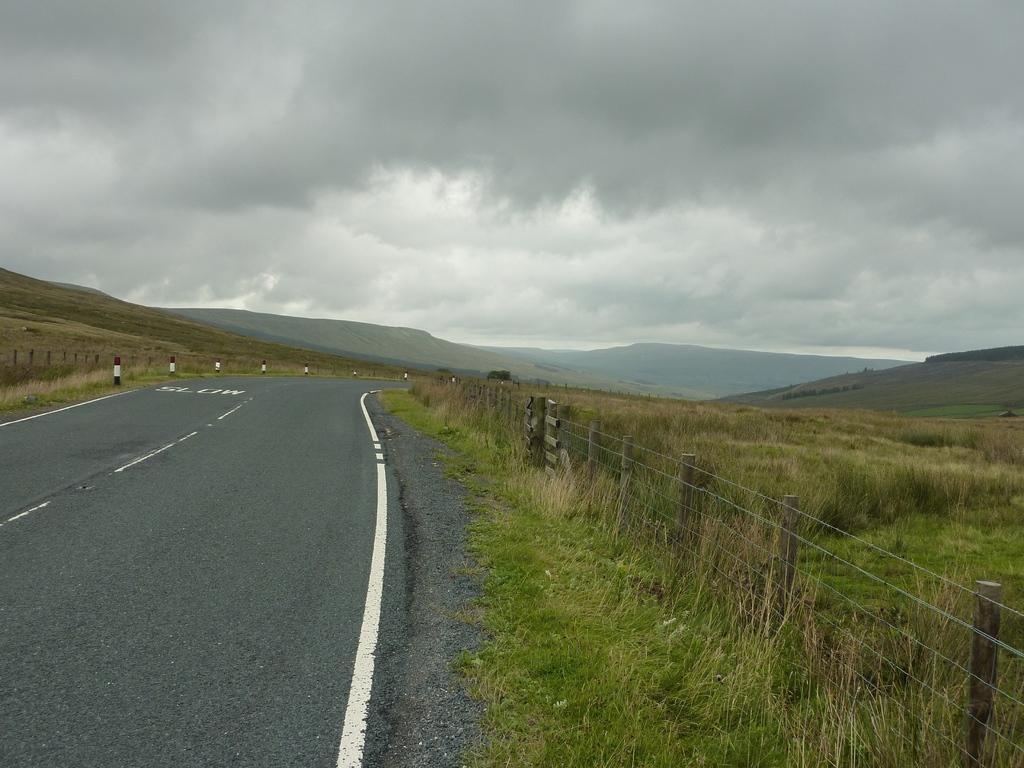Please provide a concise description of this image. In this picture we can see a road and on the left and right side of the road there are fences to the poles, grass, hills and a cloudy sky. 